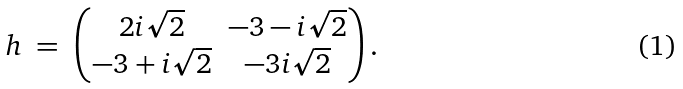<formula> <loc_0><loc_0><loc_500><loc_500>& h \ = \ \begin{pmatrix} 2 i \sqrt { 2 } & - 3 - i \sqrt { 2 } \\ - 3 + i \sqrt { 2 } & - 3 i \sqrt { 2 } \end{pmatrix} .</formula> 